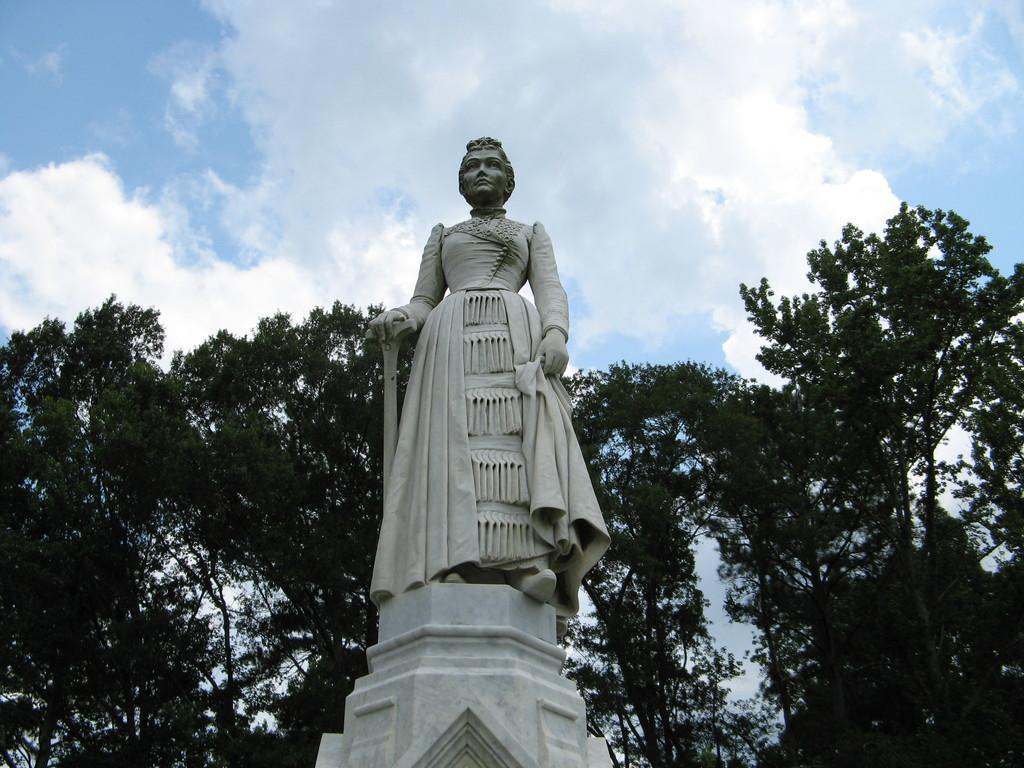What is the main subject of the image? There is a woman statue in the image. How is the statue positioned in the image? The statue is placed on a white pillar. What can be seen in the background of the image? There are trees visible in the background. What is the color of the sky in the image? The sky is blue in the image. Are there any additional features in the sky? Yes, white clouds are present in the sky. What type of force is being exerted on the statue in the image? There is no force being exerted on the statue in the image; it is stationary on the white pillar. What is the statue's reaction to the surprise in the image? There is no surprise depicted in the image, as it is a statue and not a living being. 